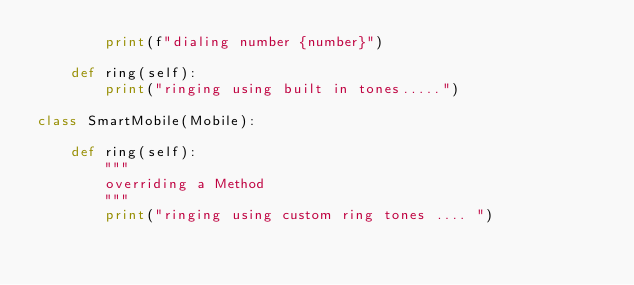Convert code to text. <code><loc_0><loc_0><loc_500><loc_500><_Python_>        print(f"dialing number {number}")

    def ring(self):
        print("ringing using built in tones.....")

class SmartMobile(Mobile):

    def ring(self):
        """
        overriding a Method
        """
        print("ringing using custom ring tones .... ")</code> 